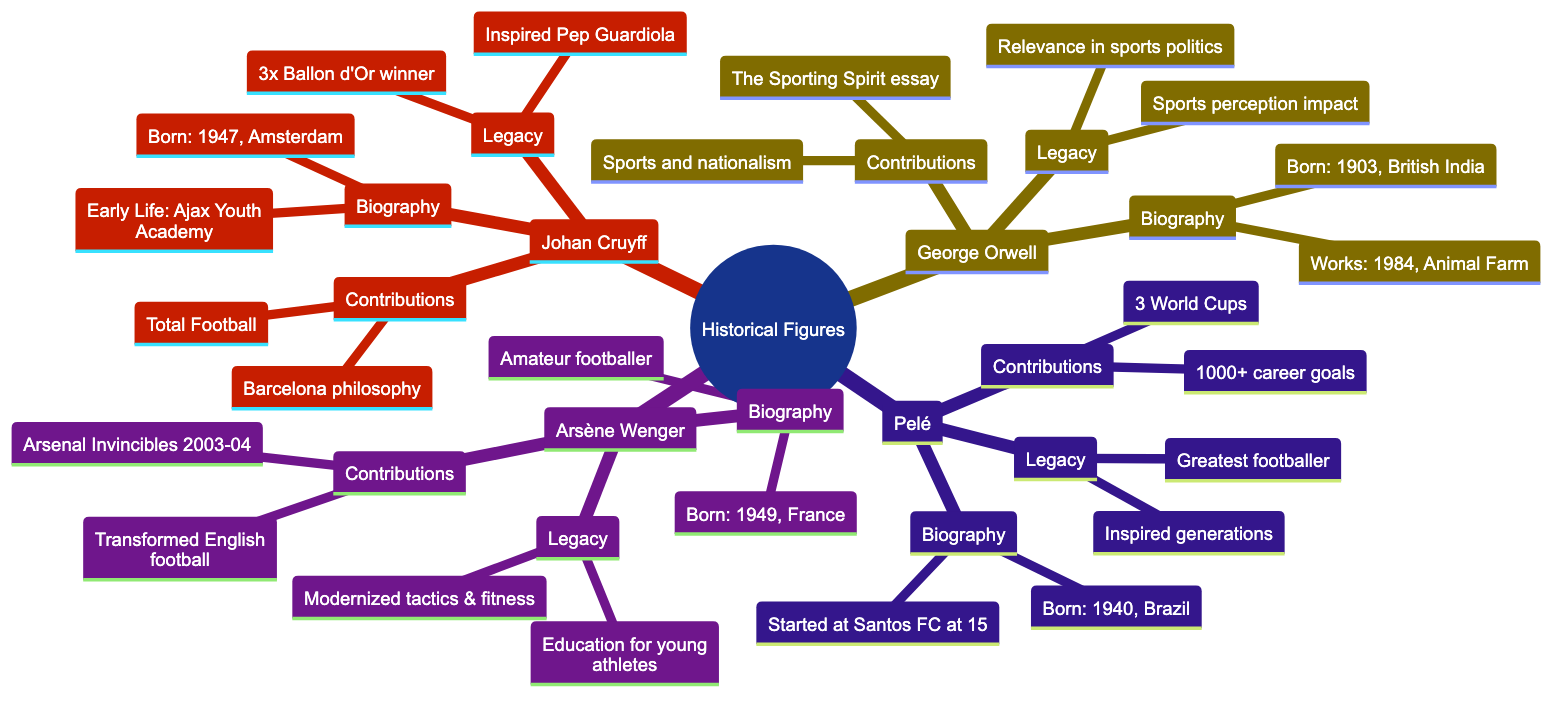What year was Johan Cruyff born? The diagram indicates that Johan Cruyff was born in 1947. This information is found in the "Biography" section under the "Johan Cruyff" branch.
Answer: 1947 Which notable work is associated with George Orwell? In the "Notable Works" sub-node of George Orwell's biography, it specifically lists '1984' and 'Animal Farm'. Both are recognized as significant literary contributions.
Answer: '1984', 'Animal Farm' How many times did Johan Cruyff win the Ballon d'Or? The "Awards" sub-node under Johan Cruyff's "Legacy" states that he won the Ballon d'Or three times. This provides a specific numerical answer to the question.
Answer: three What is a key contribution of Pelé? Looking at the "Contributions" section under the "Pelé" branch, it states that he scored over 1,000 career goals, emphasizing a significant achievement in his football career.
Answer: Scored over 1,000 career goals Who inspired Arsène Wenger's changes in English football? In the "Legacy" section of Arsène Wenger's information, it is stated that he modernized football tactics and player fitness, influencing the development of English football. This can be reasoned as being a legacy of his contributions.
Answer: Modernized football tactics What phrase describes Johan Cruyff's tactical development? Under Johan Cruyff's "Contributions," the term "Total Football" is highlighted as a key tactical development he is known for, capturing a fundamental aspect of his impact on football.
Answer: Total Football What is a cultural impact of George Orwell's writings on sports? The "Cultural Impact" sub-node under George Orwell's "Legacy" discusses how he influenced the public perception of sports, stating they are seen as more than mere games. This connects directly to his contributions to literature related to sports.
Answer: Influenced public perception of sports Which branch contains the "Invincibles" reference? The "Contributions" section of the "Arsène Wenger" branch talks about the "Invincibles," referring to Arsenal's unbeaten Premier League season. This information leads directly to the characteristic achievement of Wenger as a coach.
Answer: Arsène Wenger What major global organization did Pelé work with in promoting football? In the "Contributions" section for Pelé, it mentions his work with FIFA and the UN as a global ambassador, showcasing his role in promoting football globally through major organizations.
Answer: FIFA and the UN 